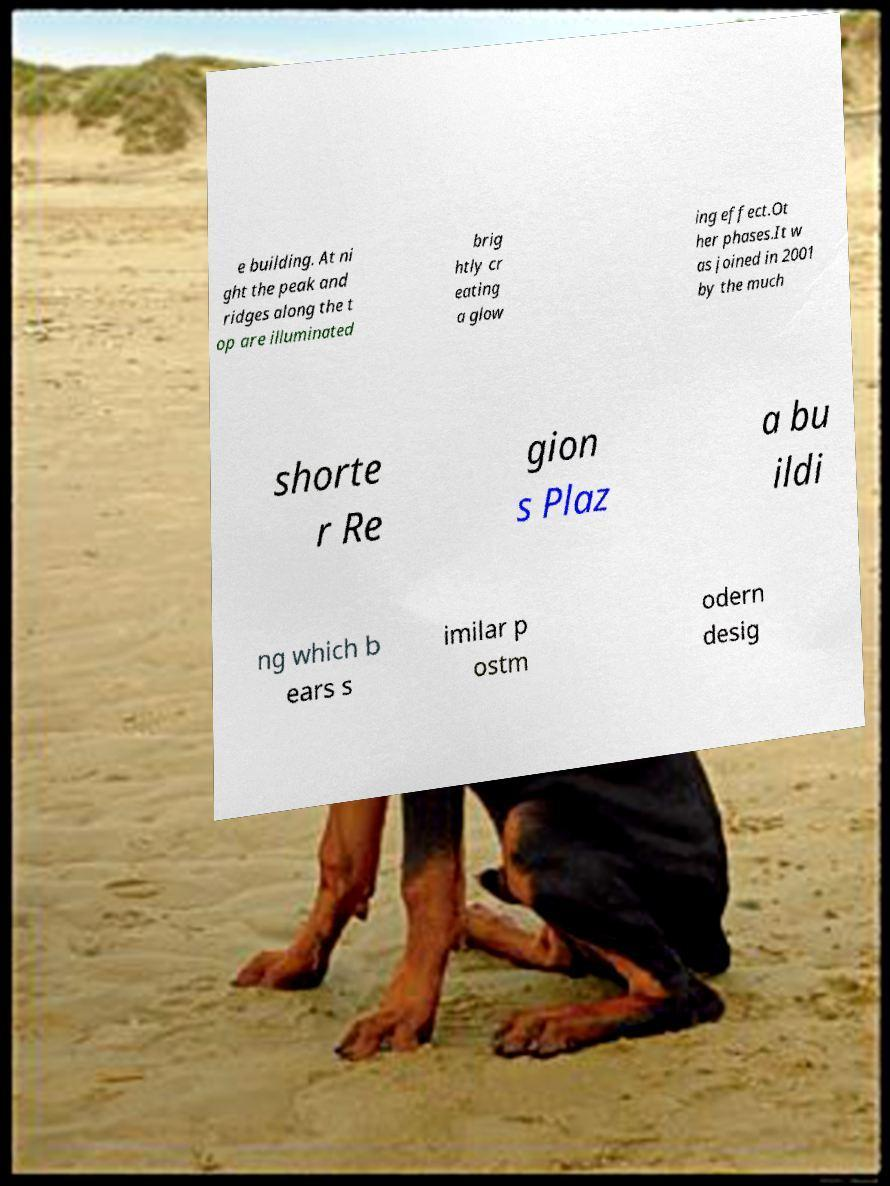Can you accurately transcribe the text from the provided image for me? e building. At ni ght the peak and ridges along the t op are illuminated brig htly cr eating a glow ing effect.Ot her phases.It w as joined in 2001 by the much shorte r Re gion s Plaz a bu ildi ng which b ears s imilar p ostm odern desig 